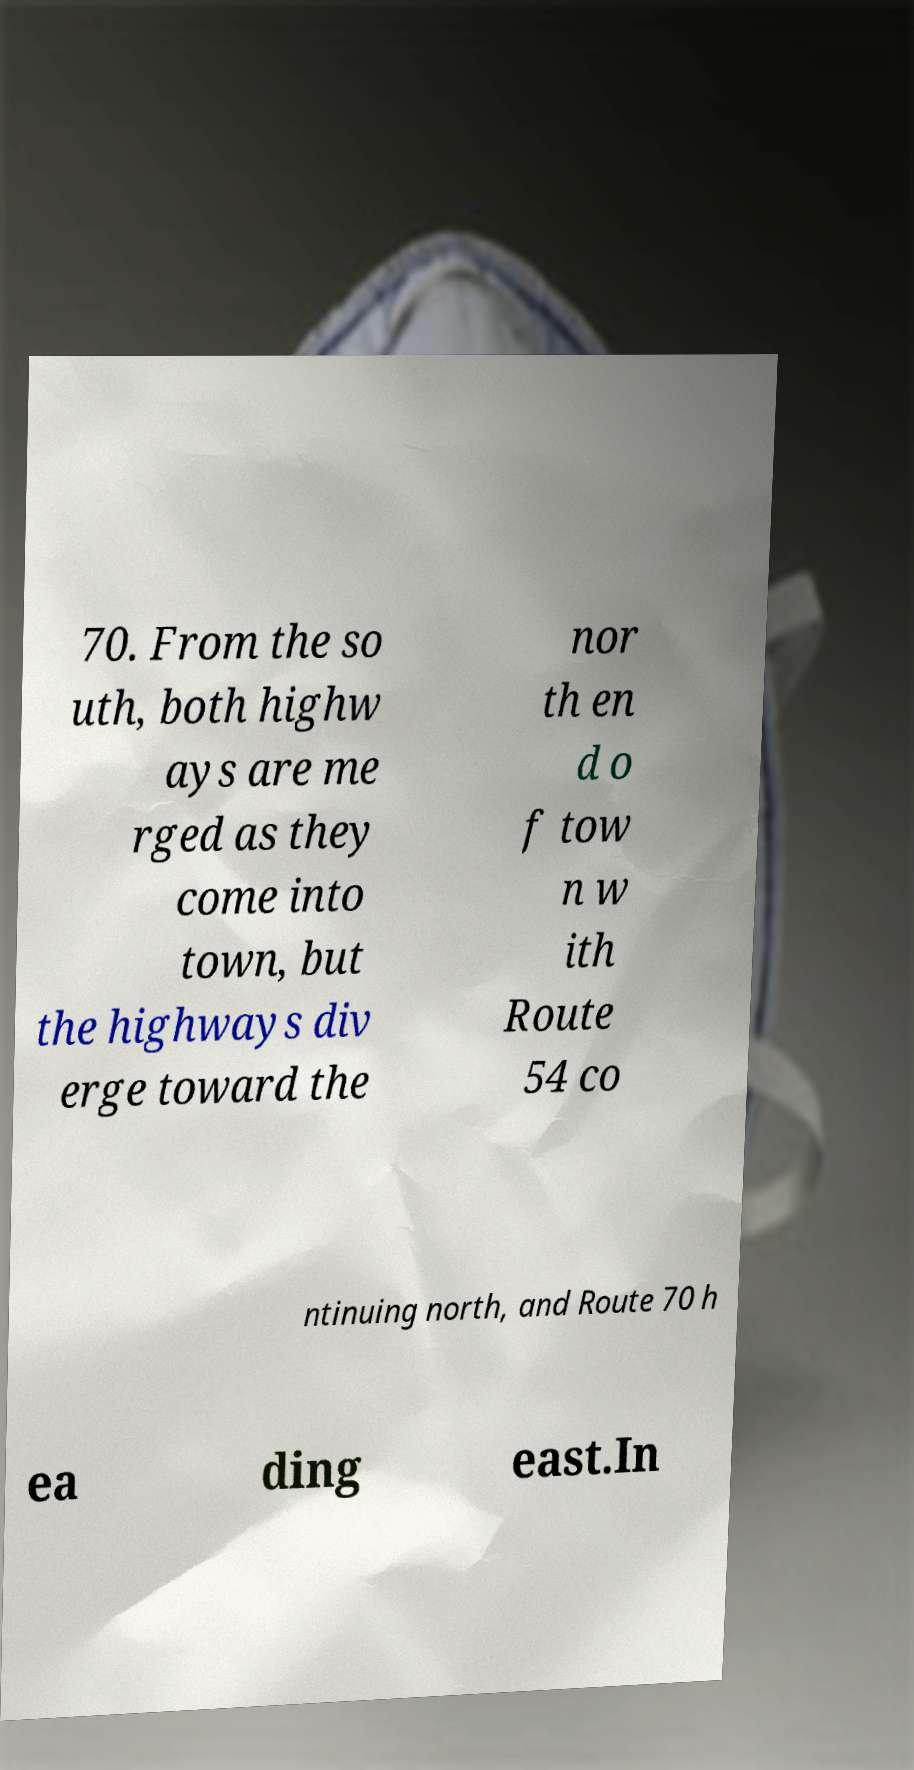Please read and relay the text visible in this image. What does it say? 70. From the so uth, both highw ays are me rged as they come into town, but the highways div erge toward the nor th en d o f tow n w ith Route 54 co ntinuing north, and Route 70 h ea ding east.In 